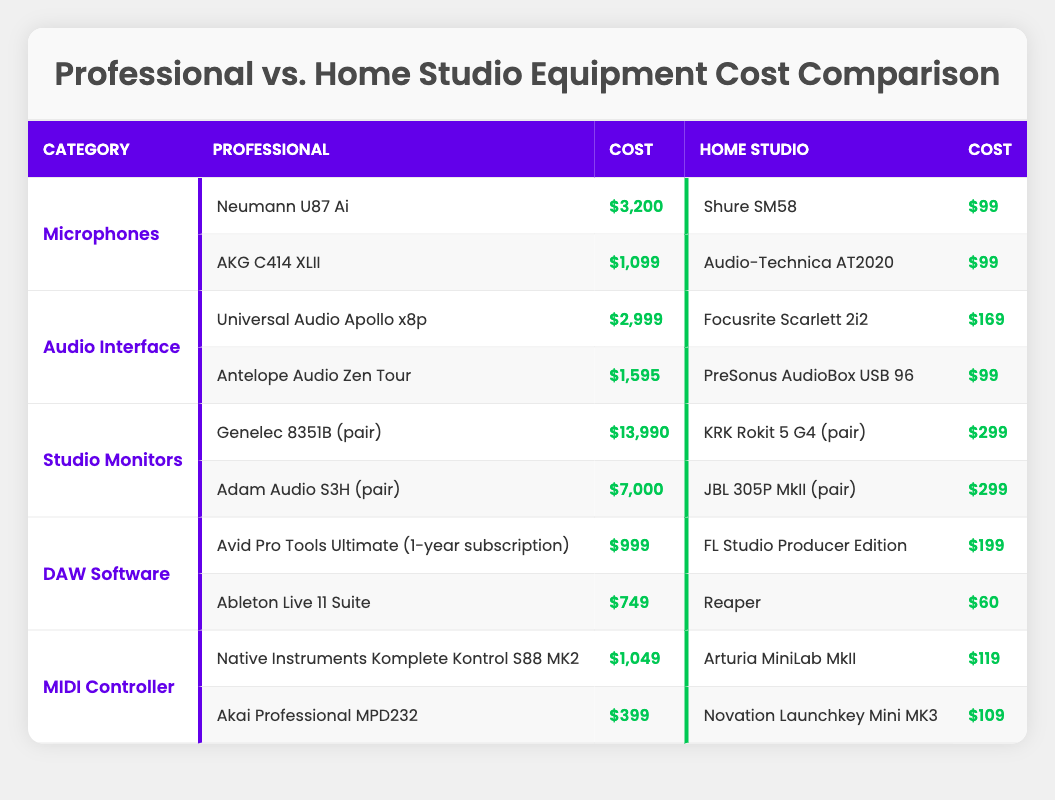What is the cost of the Neumann U87 Ai microphone? The Neumann U87 Ai is listed under the microphones category in the professional section of the table. Its cost is explicitly mentioned next to it as $3,200.
Answer: $3,200 What is the total cost of the equipment for a professional studio setup? To find the total cost, add up the costs of all professional equipment listed: $3,200 (Neumann U87 Ai) + $1,099 (AKG C414 XLII) + $2,999 (Universal Audio Apollo x8p) + $1,595 (Antelope Audio Zen Tour) + $13,990 (Genelec 8351B) + $7,000 (Adam Audio S3H) + $999 (Avid Pro Tools Ultimate) + $749 (Ableton Live 11 Suite) + $1,049 (Native Instruments Komplete Kontrol S88 MK2) + $399 (Akai Professional MPD232) = $33,080.
Answer: $33,080 Does the Audio-Technica AT2020 cost more than the Focusrite Scarlett 2i2? The cost of the Audio-Technica AT2020 is listed as $99, and the Focusrite Scarlett 2i2 is also $169. Thus, $99 is less than $169, making the statement false.
Answer: No What is the average cost of home studio microphones? The home studio microphones listed are Shure SM58 ($99) and Audio-Technica AT2020 ($99). To find the average cost, sum the costs: $99 + $99 = $198, and divide by the number of microphones (2), so the average cost is $198 / 2 = $99.
Answer: $99 What item in the professional studio monitors has the highest cost, and what is that cost? The professional studio monitors are Genelec 8351B at $13,990 and Adam Audio S3H at $7,000. The highest cost is from the Genelec 8351B, which is $13,990.
Answer: Genelec 8351B, $13,990 What is the total cost difference between the professional and home studio audio interfaces? The costs of professional audio interfaces are $2,999 (Universal Audio Apollo x8p) and $1,595 (Antelope Audio Zen Tour), giving a total of $4,594. The home studio audio interfaces are $169 (Focusrite Scarlett 2i2) and $99 (PreSonus AudioBox USB 96), totaling $268. The difference is $4,594 - $268 = $4,326.
Answer: $4,326 Are there any home studio MIDI controllers that cost more than the Akai Professional MPD232? The cost of the Akai Professional MPD232 is $399. The home studio MIDI controllers are Arturia MiniLab MkII ($119) and Novation Launchkey Mini MK3 ($109), neither of which exceeds $399. Therefore, there are no home studio MIDI controllers that cost more.
Answer: No Which category has the highest total cost in professional equipment? To determine the category with the highest total cost, we need to add the costs for each category. Microphones: $3,200 + $1,099 = $4,299; Audio Interface: $2,999 + $1,595 = $4,594; Studio Monitors: $13,990 + $7,000 = $20,990; DAW Software: $999 + $749 = $1,748; MIDI Controller: $1,049 + $399 = $1,448. The highest total is in the Studio Monitors category with $20,990.
Answer: Studio Monitors, $20,990 